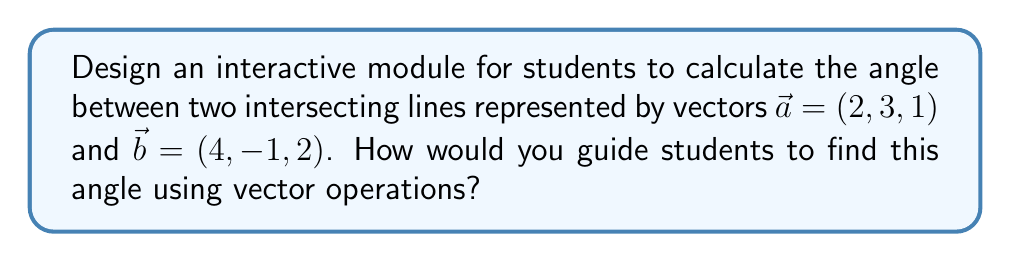Solve this math problem. To guide students in finding the angle between two intersecting lines using vector operations, follow these steps:

1. Explain that the angle between two vectors is the same as the angle between two lines they represent.

2. Introduce the formula for the angle $\theta$ between two vectors $\vec{a}$ and $\vec{b}$:

   $$\cos \theta = \frac{\vec{a} \cdot \vec{b}}{|\vec{a}||\vec{b}|}$$

3. Calculate the dot product $\vec{a} \cdot \vec{b}$:
   $$\vec{a} \cdot \vec{b} = (2)(4) + (3)(-1) + (1)(2) = 8 - 3 + 2 = 7$$

4. Calculate the magnitudes of the vectors:
   $$|\vec{a}| = \sqrt{2^2 + 3^2 + 1^2} = \sqrt{14}$$
   $$|\vec{b}| = \sqrt{4^2 + (-1)^2 + 2^2} = \sqrt{21}$$

5. Substitute these values into the formula:
   $$\cos \theta = \frac{7}{\sqrt{14} \cdot \sqrt{21}}$$

6. Simplify:
   $$\cos \theta = \frac{7}{\sqrt{294}}$$

7. Take the inverse cosine (arccos) of both sides:
   $$\theta = \arccos\left(\frac{7}{\sqrt{294}}\right)$$

8. Calculate the final answer using a calculator:
   $$\theta \approx 0.8621 \text{ radians}$$

9. Convert to degrees if needed:
   $$\theta \approx 49.39°$$

Encourage students to visualize the process using an interactive 3D graph where they can manipulate the vectors and see how the angle changes.
Answer: $\theta = \arccos\left(\frac{7}{\sqrt{294}}\right) \approx 49.39°$ 